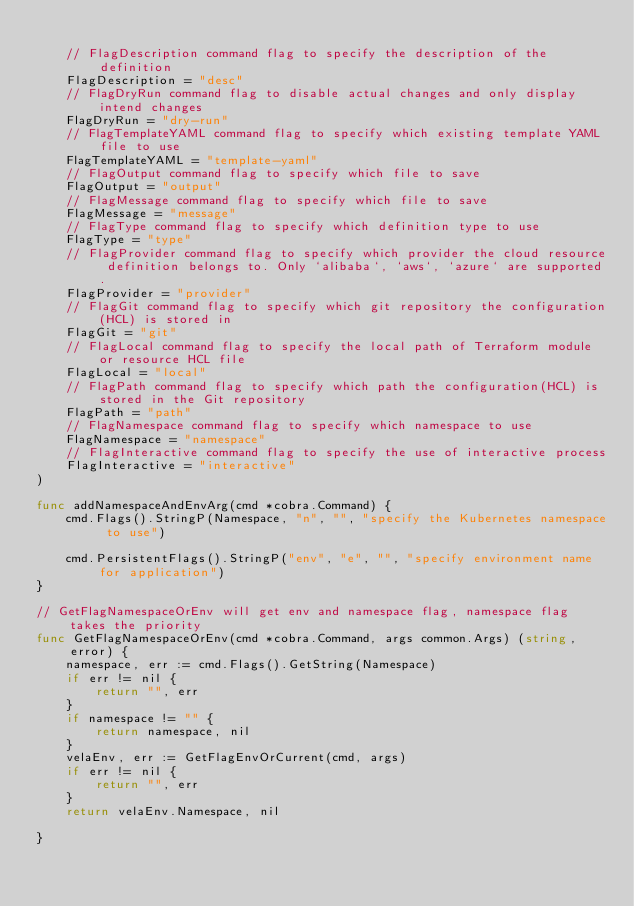<code> <loc_0><loc_0><loc_500><loc_500><_Go_>
	// FlagDescription command flag to specify the description of the definition
	FlagDescription = "desc"
	// FlagDryRun command flag to disable actual changes and only display intend changes
	FlagDryRun = "dry-run"
	// FlagTemplateYAML command flag to specify which existing template YAML file to use
	FlagTemplateYAML = "template-yaml"
	// FlagOutput command flag to specify which file to save
	FlagOutput = "output"
	// FlagMessage command flag to specify which file to save
	FlagMessage = "message"
	// FlagType command flag to specify which definition type to use
	FlagType = "type"
	// FlagProvider command flag to specify which provider the cloud resource definition belongs to. Only `alibaba`, `aws`, `azure` are supported.
	FlagProvider = "provider"
	// FlagGit command flag to specify which git repository the configuration(HCL) is stored in
	FlagGit = "git"
	// FlagLocal command flag to specify the local path of Terraform module or resource HCL file
	FlagLocal = "local"
	// FlagPath command flag to specify which path the configuration(HCL) is stored in the Git repository
	FlagPath = "path"
	// FlagNamespace command flag to specify which namespace to use
	FlagNamespace = "namespace"
	// FlagInteractive command flag to specify the use of interactive process
	FlagInteractive = "interactive"
)

func addNamespaceAndEnvArg(cmd *cobra.Command) {
	cmd.Flags().StringP(Namespace, "n", "", "specify the Kubernetes namespace to use")

	cmd.PersistentFlags().StringP("env", "e", "", "specify environment name for application")
}

// GetFlagNamespaceOrEnv will get env and namespace flag, namespace flag takes the priority
func GetFlagNamespaceOrEnv(cmd *cobra.Command, args common.Args) (string, error) {
	namespace, err := cmd.Flags().GetString(Namespace)
	if err != nil {
		return "", err
	}
	if namespace != "" {
		return namespace, nil
	}
	velaEnv, err := GetFlagEnvOrCurrent(cmd, args)
	if err != nil {
		return "", err
	}
	return velaEnv.Namespace, nil

}
</code> 